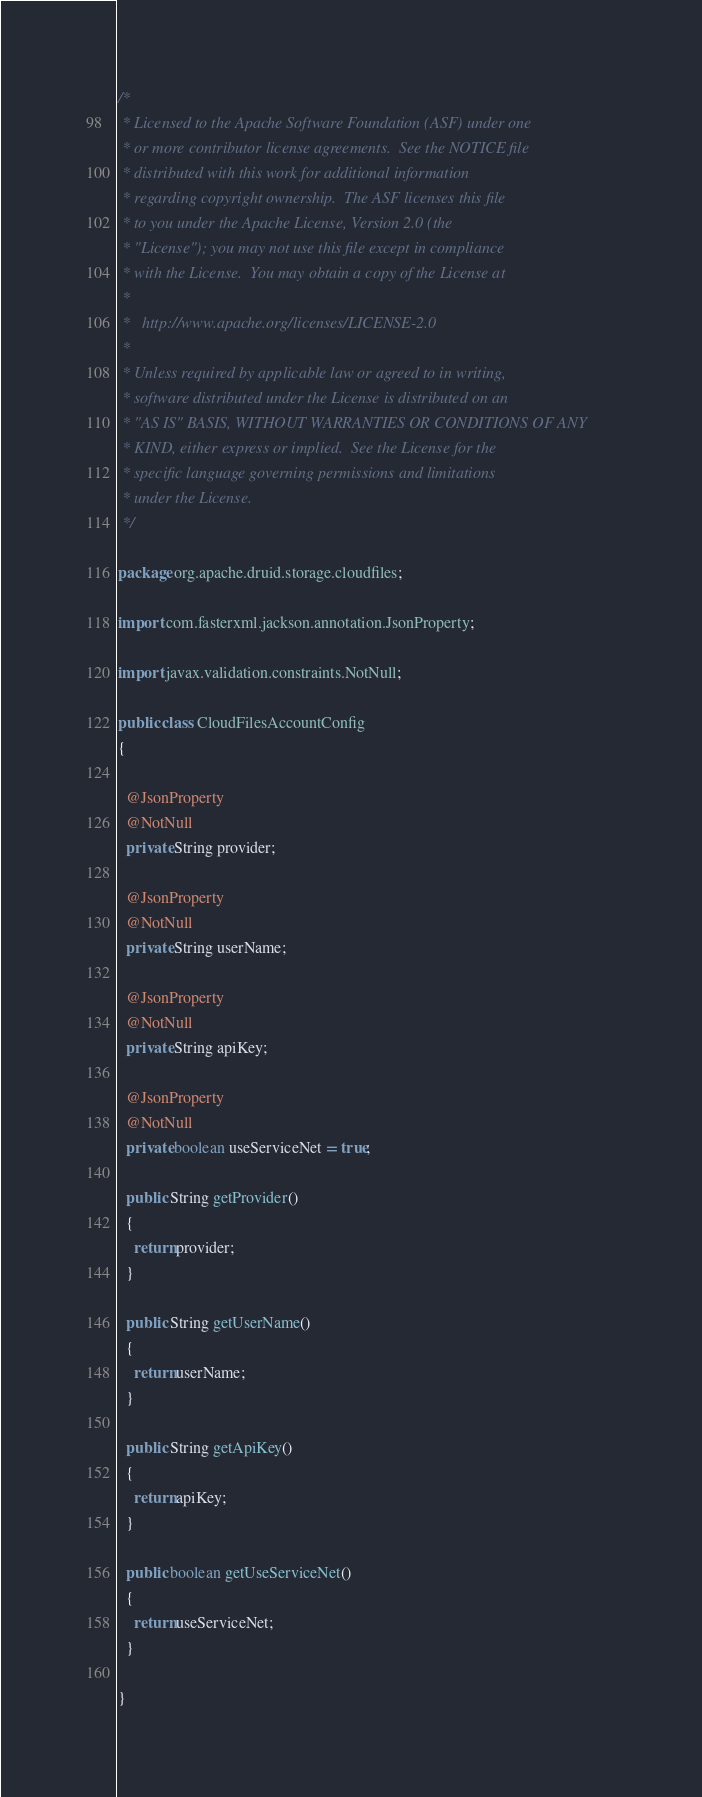Convert code to text. <code><loc_0><loc_0><loc_500><loc_500><_Java_>/*
 * Licensed to the Apache Software Foundation (ASF) under one
 * or more contributor license agreements.  See the NOTICE file
 * distributed with this work for additional information
 * regarding copyright ownership.  The ASF licenses this file
 * to you under the Apache License, Version 2.0 (the
 * "License"); you may not use this file except in compliance
 * with the License.  You may obtain a copy of the License at
 *
 *   http://www.apache.org/licenses/LICENSE-2.0
 *
 * Unless required by applicable law or agreed to in writing,
 * software distributed under the License is distributed on an
 * "AS IS" BASIS, WITHOUT WARRANTIES OR CONDITIONS OF ANY
 * KIND, either express or implied.  See the License for the
 * specific language governing permissions and limitations
 * under the License.
 */

package org.apache.druid.storage.cloudfiles;

import com.fasterxml.jackson.annotation.JsonProperty;

import javax.validation.constraints.NotNull;

public class CloudFilesAccountConfig
{

  @JsonProperty
  @NotNull
  private String provider;

  @JsonProperty
  @NotNull
  private String userName;

  @JsonProperty
  @NotNull
  private String apiKey;

  @JsonProperty
  @NotNull
  private boolean useServiceNet = true;

  public String getProvider()
  {
    return provider;
  }

  public String getUserName()
  {
    return userName;
  }

  public String getApiKey()
  {
    return apiKey;
  }

  public boolean getUseServiceNet()
  {
    return useServiceNet;
  }

}
</code> 